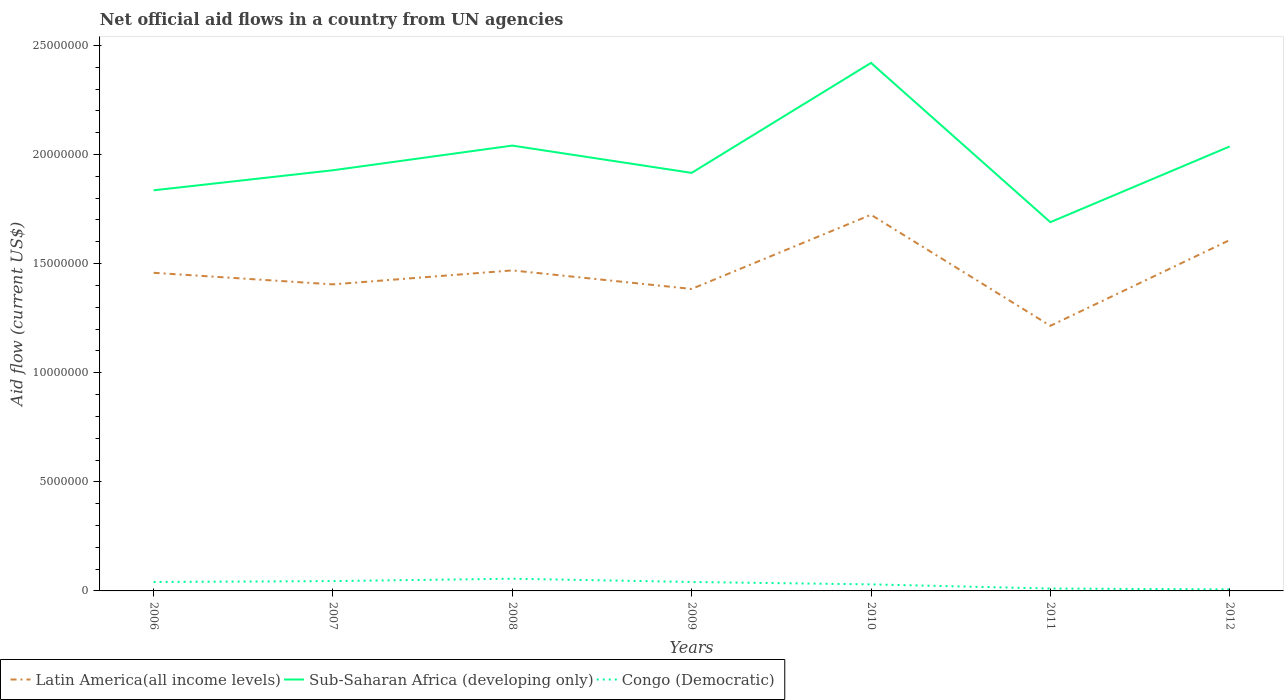Across all years, what is the maximum net official aid flow in Latin America(all income levels)?
Offer a very short reply. 1.22e+07. What is the total net official aid flow in Latin America(all income levels) in the graph?
Offer a very short reply. 2.10e+05. What is the difference between the highest and the second highest net official aid flow in Sub-Saharan Africa (developing only)?
Your answer should be compact. 7.30e+06. How many years are there in the graph?
Provide a short and direct response. 7. Are the values on the major ticks of Y-axis written in scientific E-notation?
Provide a succinct answer. No. Does the graph contain any zero values?
Your answer should be compact. No. Where does the legend appear in the graph?
Your answer should be very brief. Bottom left. How many legend labels are there?
Ensure brevity in your answer.  3. What is the title of the graph?
Your answer should be compact. Net official aid flows in a country from UN agencies. What is the Aid flow (current US$) in Latin America(all income levels) in 2006?
Your response must be concise. 1.46e+07. What is the Aid flow (current US$) in Sub-Saharan Africa (developing only) in 2006?
Provide a succinct answer. 1.84e+07. What is the Aid flow (current US$) in Congo (Democratic) in 2006?
Provide a succinct answer. 4.10e+05. What is the Aid flow (current US$) in Latin America(all income levels) in 2007?
Ensure brevity in your answer.  1.40e+07. What is the Aid flow (current US$) in Sub-Saharan Africa (developing only) in 2007?
Provide a succinct answer. 1.93e+07. What is the Aid flow (current US$) of Congo (Democratic) in 2007?
Provide a short and direct response. 4.50e+05. What is the Aid flow (current US$) in Latin America(all income levels) in 2008?
Your answer should be compact. 1.47e+07. What is the Aid flow (current US$) in Sub-Saharan Africa (developing only) in 2008?
Provide a short and direct response. 2.04e+07. What is the Aid flow (current US$) in Congo (Democratic) in 2008?
Make the answer very short. 5.60e+05. What is the Aid flow (current US$) of Latin America(all income levels) in 2009?
Your answer should be compact. 1.38e+07. What is the Aid flow (current US$) of Sub-Saharan Africa (developing only) in 2009?
Offer a terse response. 1.92e+07. What is the Aid flow (current US$) of Latin America(all income levels) in 2010?
Offer a terse response. 1.72e+07. What is the Aid flow (current US$) of Sub-Saharan Africa (developing only) in 2010?
Provide a short and direct response. 2.42e+07. What is the Aid flow (current US$) of Latin America(all income levels) in 2011?
Make the answer very short. 1.22e+07. What is the Aid flow (current US$) in Sub-Saharan Africa (developing only) in 2011?
Your answer should be very brief. 1.69e+07. What is the Aid flow (current US$) of Congo (Democratic) in 2011?
Your answer should be compact. 1.10e+05. What is the Aid flow (current US$) of Latin America(all income levels) in 2012?
Provide a short and direct response. 1.61e+07. What is the Aid flow (current US$) in Sub-Saharan Africa (developing only) in 2012?
Provide a succinct answer. 2.04e+07. Across all years, what is the maximum Aid flow (current US$) in Latin America(all income levels)?
Your answer should be compact. 1.72e+07. Across all years, what is the maximum Aid flow (current US$) in Sub-Saharan Africa (developing only)?
Your response must be concise. 2.42e+07. Across all years, what is the maximum Aid flow (current US$) of Congo (Democratic)?
Give a very brief answer. 5.60e+05. Across all years, what is the minimum Aid flow (current US$) in Latin America(all income levels)?
Keep it short and to the point. 1.22e+07. Across all years, what is the minimum Aid flow (current US$) in Sub-Saharan Africa (developing only)?
Offer a very short reply. 1.69e+07. What is the total Aid flow (current US$) of Latin America(all income levels) in the graph?
Your answer should be very brief. 1.03e+08. What is the total Aid flow (current US$) in Sub-Saharan Africa (developing only) in the graph?
Ensure brevity in your answer.  1.39e+08. What is the total Aid flow (current US$) in Congo (Democratic) in the graph?
Ensure brevity in your answer.  2.31e+06. What is the difference between the Aid flow (current US$) in Latin America(all income levels) in 2006 and that in 2007?
Your answer should be very brief. 5.30e+05. What is the difference between the Aid flow (current US$) in Sub-Saharan Africa (developing only) in 2006 and that in 2007?
Your response must be concise. -9.20e+05. What is the difference between the Aid flow (current US$) of Congo (Democratic) in 2006 and that in 2007?
Offer a terse response. -4.00e+04. What is the difference between the Aid flow (current US$) in Sub-Saharan Africa (developing only) in 2006 and that in 2008?
Offer a terse response. -2.05e+06. What is the difference between the Aid flow (current US$) of Latin America(all income levels) in 2006 and that in 2009?
Ensure brevity in your answer.  7.40e+05. What is the difference between the Aid flow (current US$) in Sub-Saharan Africa (developing only) in 2006 and that in 2009?
Provide a succinct answer. -8.00e+05. What is the difference between the Aid flow (current US$) in Congo (Democratic) in 2006 and that in 2009?
Your answer should be very brief. 0. What is the difference between the Aid flow (current US$) of Latin America(all income levels) in 2006 and that in 2010?
Your answer should be very brief. -2.66e+06. What is the difference between the Aid flow (current US$) in Sub-Saharan Africa (developing only) in 2006 and that in 2010?
Your answer should be very brief. -5.84e+06. What is the difference between the Aid flow (current US$) of Latin America(all income levels) in 2006 and that in 2011?
Provide a succinct answer. 2.43e+06. What is the difference between the Aid flow (current US$) of Sub-Saharan Africa (developing only) in 2006 and that in 2011?
Your answer should be compact. 1.46e+06. What is the difference between the Aid flow (current US$) of Congo (Democratic) in 2006 and that in 2011?
Provide a succinct answer. 3.00e+05. What is the difference between the Aid flow (current US$) of Latin America(all income levels) in 2006 and that in 2012?
Offer a terse response. -1.50e+06. What is the difference between the Aid flow (current US$) in Sub-Saharan Africa (developing only) in 2006 and that in 2012?
Provide a succinct answer. -2.01e+06. What is the difference between the Aid flow (current US$) of Latin America(all income levels) in 2007 and that in 2008?
Offer a terse response. -6.40e+05. What is the difference between the Aid flow (current US$) in Sub-Saharan Africa (developing only) in 2007 and that in 2008?
Provide a short and direct response. -1.13e+06. What is the difference between the Aid flow (current US$) of Congo (Democratic) in 2007 and that in 2008?
Your response must be concise. -1.10e+05. What is the difference between the Aid flow (current US$) of Sub-Saharan Africa (developing only) in 2007 and that in 2009?
Offer a terse response. 1.20e+05. What is the difference between the Aid flow (current US$) of Congo (Democratic) in 2007 and that in 2009?
Offer a terse response. 4.00e+04. What is the difference between the Aid flow (current US$) of Latin America(all income levels) in 2007 and that in 2010?
Offer a terse response. -3.19e+06. What is the difference between the Aid flow (current US$) of Sub-Saharan Africa (developing only) in 2007 and that in 2010?
Provide a short and direct response. -4.92e+06. What is the difference between the Aid flow (current US$) in Latin America(all income levels) in 2007 and that in 2011?
Provide a succinct answer. 1.90e+06. What is the difference between the Aid flow (current US$) in Sub-Saharan Africa (developing only) in 2007 and that in 2011?
Provide a short and direct response. 2.38e+06. What is the difference between the Aid flow (current US$) in Congo (Democratic) in 2007 and that in 2011?
Offer a terse response. 3.40e+05. What is the difference between the Aid flow (current US$) of Latin America(all income levels) in 2007 and that in 2012?
Your answer should be very brief. -2.03e+06. What is the difference between the Aid flow (current US$) in Sub-Saharan Africa (developing only) in 2007 and that in 2012?
Provide a succinct answer. -1.09e+06. What is the difference between the Aid flow (current US$) of Latin America(all income levels) in 2008 and that in 2009?
Provide a succinct answer. 8.50e+05. What is the difference between the Aid flow (current US$) of Sub-Saharan Africa (developing only) in 2008 and that in 2009?
Your answer should be compact. 1.25e+06. What is the difference between the Aid flow (current US$) of Latin America(all income levels) in 2008 and that in 2010?
Offer a terse response. -2.55e+06. What is the difference between the Aid flow (current US$) in Sub-Saharan Africa (developing only) in 2008 and that in 2010?
Give a very brief answer. -3.79e+06. What is the difference between the Aid flow (current US$) in Latin America(all income levels) in 2008 and that in 2011?
Ensure brevity in your answer.  2.54e+06. What is the difference between the Aid flow (current US$) in Sub-Saharan Africa (developing only) in 2008 and that in 2011?
Make the answer very short. 3.51e+06. What is the difference between the Aid flow (current US$) in Congo (Democratic) in 2008 and that in 2011?
Provide a short and direct response. 4.50e+05. What is the difference between the Aid flow (current US$) in Latin America(all income levels) in 2008 and that in 2012?
Offer a very short reply. -1.39e+06. What is the difference between the Aid flow (current US$) of Congo (Democratic) in 2008 and that in 2012?
Make the answer very short. 4.90e+05. What is the difference between the Aid flow (current US$) of Latin America(all income levels) in 2009 and that in 2010?
Your response must be concise. -3.40e+06. What is the difference between the Aid flow (current US$) in Sub-Saharan Africa (developing only) in 2009 and that in 2010?
Give a very brief answer. -5.04e+06. What is the difference between the Aid flow (current US$) in Latin America(all income levels) in 2009 and that in 2011?
Offer a very short reply. 1.69e+06. What is the difference between the Aid flow (current US$) in Sub-Saharan Africa (developing only) in 2009 and that in 2011?
Provide a succinct answer. 2.26e+06. What is the difference between the Aid flow (current US$) of Latin America(all income levels) in 2009 and that in 2012?
Your answer should be very brief. -2.24e+06. What is the difference between the Aid flow (current US$) in Sub-Saharan Africa (developing only) in 2009 and that in 2012?
Your answer should be compact. -1.21e+06. What is the difference between the Aid flow (current US$) in Latin America(all income levels) in 2010 and that in 2011?
Your response must be concise. 5.09e+06. What is the difference between the Aid flow (current US$) in Sub-Saharan Africa (developing only) in 2010 and that in 2011?
Your answer should be compact. 7.30e+06. What is the difference between the Aid flow (current US$) in Congo (Democratic) in 2010 and that in 2011?
Your answer should be very brief. 1.90e+05. What is the difference between the Aid flow (current US$) of Latin America(all income levels) in 2010 and that in 2012?
Give a very brief answer. 1.16e+06. What is the difference between the Aid flow (current US$) of Sub-Saharan Africa (developing only) in 2010 and that in 2012?
Give a very brief answer. 3.83e+06. What is the difference between the Aid flow (current US$) of Latin America(all income levels) in 2011 and that in 2012?
Your answer should be compact. -3.93e+06. What is the difference between the Aid flow (current US$) of Sub-Saharan Africa (developing only) in 2011 and that in 2012?
Your answer should be very brief. -3.47e+06. What is the difference between the Aid flow (current US$) in Latin America(all income levels) in 2006 and the Aid flow (current US$) in Sub-Saharan Africa (developing only) in 2007?
Provide a succinct answer. -4.70e+06. What is the difference between the Aid flow (current US$) in Latin America(all income levels) in 2006 and the Aid flow (current US$) in Congo (Democratic) in 2007?
Ensure brevity in your answer.  1.41e+07. What is the difference between the Aid flow (current US$) in Sub-Saharan Africa (developing only) in 2006 and the Aid flow (current US$) in Congo (Democratic) in 2007?
Keep it short and to the point. 1.79e+07. What is the difference between the Aid flow (current US$) in Latin America(all income levels) in 2006 and the Aid flow (current US$) in Sub-Saharan Africa (developing only) in 2008?
Ensure brevity in your answer.  -5.83e+06. What is the difference between the Aid flow (current US$) in Latin America(all income levels) in 2006 and the Aid flow (current US$) in Congo (Democratic) in 2008?
Give a very brief answer. 1.40e+07. What is the difference between the Aid flow (current US$) of Sub-Saharan Africa (developing only) in 2006 and the Aid flow (current US$) of Congo (Democratic) in 2008?
Offer a very short reply. 1.78e+07. What is the difference between the Aid flow (current US$) in Latin America(all income levels) in 2006 and the Aid flow (current US$) in Sub-Saharan Africa (developing only) in 2009?
Offer a terse response. -4.58e+06. What is the difference between the Aid flow (current US$) in Latin America(all income levels) in 2006 and the Aid flow (current US$) in Congo (Democratic) in 2009?
Your answer should be compact. 1.42e+07. What is the difference between the Aid flow (current US$) in Sub-Saharan Africa (developing only) in 2006 and the Aid flow (current US$) in Congo (Democratic) in 2009?
Your response must be concise. 1.80e+07. What is the difference between the Aid flow (current US$) of Latin America(all income levels) in 2006 and the Aid flow (current US$) of Sub-Saharan Africa (developing only) in 2010?
Offer a very short reply. -9.62e+06. What is the difference between the Aid flow (current US$) of Latin America(all income levels) in 2006 and the Aid flow (current US$) of Congo (Democratic) in 2010?
Keep it short and to the point. 1.43e+07. What is the difference between the Aid flow (current US$) in Sub-Saharan Africa (developing only) in 2006 and the Aid flow (current US$) in Congo (Democratic) in 2010?
Your answer should be compact. 1.81e+07. What is the difference between the Aid flow (current US$) in Latin America(all income levels) in 2006 and the Aid flow (current US$) in Sub-Saharan Africa (developing only) in 2011?
Ensure brevity in your answer.  -2.32e+06. What is the difference between the Aid flow (current US$) of Latin America(all income levels) in 2006 and the Aid flow (current US$) of Congo (Democratic) in 2011?
Offer a terse response. 1.45e+07. What is the difference between the Aid flow (current US$) of Sub-Saharan Africa (developing only) in 2006 and the Aid flow (current US$) of Congo (Democratic) in 2011?
Give a very brief answer. 1.82e+07. What is the difference between the Aid flow (current US$) of Latin America(all income levels) in 2006 and the Aid flow (current US$) of Sub-Saharan Africa (developing only) in 2012?
Provide a short and direct response. -5.79e+06. What is the difference between the Aid flow (current US$) of Latin America(all income levels) in 2006 and the Aid flow (current US$) of Congo (Democratic) in 2012?
Ensure brevity in your answer.  1.45e+07. What is the difference between the Aid flow (current US$) of Sub-Saharan Africa (developing only) in 2006 and the Aid flow (current US$) of Congo (Democratic) in 2012?
Your answer should be very brief. 1.83e+07. What is the difference between the Aid flow (current US$) in Latin America(all income levels) in 2007 and the Aid flow (current US$) in Sub-Saharan Africa (developing only) in 2008?
Make the answer very short. -6.36e+06. What is the difference between the Aid flow (current US$) of Latin America(all income levels) in 2007 and the Aid flow (current US$) of Congo (Democratic) in 2008?
Ensure brevity in your answer.  1.35e+07. What is the difference between the Aid flow (current US$) of Sub-Saharan Africa (developing only) in 2007 and the Aid flow (current US$) of Congo (Democratic) in 2008?
Your answer should be very brief. 1.87e+07. What is the difference between the Aid flow (current US$) in Latin America(all income levels) in 2007 and the Aid flow (current US$) in Sub-Saharan Africa (developing only) in 2009?
Your answer should be very brief. -5.11e+06. What is the difference between the Aid flow (current US$) of Latin America(all income levels) in 2007 and the Aid flow (current US$) of Congo (Democratic) in 2009?
Offer a terse response. 1.36e+07. What is the difference between the Aid flow (current US$) of Sub-Saharan Africa (developing only) in 2007 and the Aid flow (current US$) of Congo (Democratic) in 2009?
Provide a short and direct response. 1.89e+07. What is the difference between the Aid flow (current US$) of Latin America(all income levels) in 2007 and the Aid flow (current US$) of Sub-Saharan Africa (developing only) in 2010?
Your answer should be compact. -1.02e+07. What is the difference between the Aid flow (current US$) of Latin America(all income levels) in 2007 and the Aid flow (current US$) of Congo (Democratic) in 2010?
Give a very brief answer. 1.38e+07. What is the difference between the Aid flow (current US$) in Sub-Saharan Africa (developing only) in 2007 and the Aid flow (current US$) in Congo (Democratic) in 2010?
Give a very brief answer. 1.90e+07. What is the difference between the Aid flow (current US$) in Latin America(all income levels) in 2007 and the Aid flow (current US$) in Sub-Saharan Africa (developing only) in 2011?
Ensure brevity in your answer.  -2.85e+06. What is the difference between the Aid flow (current US$) of Latin America(all income levels) in 2007 and the Aid flow (current US$) of Congo (Democratic) in 2011?
Give a very brief answer. 1.39e+07. What is the difference between the Aid flow (current US$) in Sub-Saharan Africa (developing only) in 2007 and the Aid flow (current US$) in Congo (Democratic) in 2011?
Your answer should be compact. 1.92e+07. What is the difference between the Aid flow (current US$) in Latin America(all income levels) in 2007 and the Aid flow (current US$) in Sub-Saharan Africa (developing only) in 2012?
Provide a succinct answer. -6.32e+06. What is the difference between the Aid flow (current US$) of Latin America(all income levels) in 2007 and the Aid flow (current US$) of Congo (Democratic) in 2012?
Your answer should be very brief. 1.40e+07. What is the difference between the Aid flow (current US$) of Sub-Saharan Africa (developing only) in 2007 and the Aid flow (current US$) of Congo (Democratic) in 2012?
Make the answer very short. 1.92e+07. What is the difference between the Aid flow (current US$) of Latin America(all income levels) in 2008 and the Aid flow (current US$) of Sub-Saharan Africa (developing only) in 2009?
Provide a succinct answer. -4.47e+06. What is the difference between the Aid flow (current US$) in Latin America(all income levels) in 2008 and the Aid flow (current US$) in Congo (Democratic) in 2009?
Give a very brief answer. 1.43e+07. What is the difference between the Aid flow (current US$) of Latin America(all income levels) in 2008 and the Aid flow (current US$) of Sub-Saharan Africa (developing only) in 2010?
Give a very brief answer. -9.51e+06. What is the difference between the Aid flow (current US$) of Latin America(all income levels) in 2008 and the Aid flow (current US$) of Congo (Democratic) in 2010?
Provide a short and direct response. 1.44e+07. What is the difference between the Aid flow (current US$) in Sub-Saharan Africa (developing only) in 2008 and the Aid flow (current US$) in Congo (Democratic) in 2010?
Your answer should be very brief. 2.01e+07. What is the difference between the Aid flow (current US$) of Latin America(all income levels) in 2008 and the Aid flow (current US$) of Sub-Saharan Africa (developing only) in 2011?
Provide a short and direct response. -2.21e+06. What is the difference between the Aid flow (current US$) in Latin America(all income levels) in 2008 and the Aid flow (current US$) in Congo (Democratic) in 2011?
Keep it short and to the point. 1.46e+07. What is the difference between the Aid flow (current US$) of Sub-Saharan Africa (developing only) in 2008 and the Aid flow (current US$) of Congo (Democratic) in 2011?
Ensure brevity in your answer.  2.03e+07. What is the difference between the Aid flow (current US$) of Latin America(all income levels) in 2008 and the Aid flow (current US$) of Sub-Saharan Africa (developing only) in 2012?
Ensure brevity in your answer.  -5.68e+06. What is the difference between the Aid flow (current US$) of Latin America(all income levels) in 2008 and the Aid flow (current US$) of Congo (Democratic) in 2012?
Keep it short and to the point. 1.46e+07. What is the difference between the Aid flow (current US$) of Sub-Saharan Africa (developing only) in 2008 and the Aid flow (current US$) of Congo (Democratic) in 2012?
Your response must be concise. 2.03e+07. What is the difference between the Aid flow (current US$) of Latin America(all income levels) in 2009 and the Aid flow (current US$) of Sub-Saharan Africa (developing only) in 2010?
Make the answer very short. -1.04e+07. What is the difference between the Aid flow (current US$) of Latin America(all income levels) in 2009 and the Aid flow (current US$) of Congo (Democratic) in 2010?
Provide a succinct answer. 1.35e+07. What is the difference between the Aid flow (current US$) in Sub-Saharan Africa (developing only) in 2009 and the Aid flow (current US$) in Congo (Democratic) in 2010?
Ensure brevity in your answer.  1.89e+07. What is the difference between the Aid flow (current US$) in Latin America(all income levels) in 2009 and the Aid flow (current US$) in Sub-Saharan Africa (developing only) in 2011?
Give a very brief answer. -3.06e+06. What is the difference between the Aid flow (current US$) in Latin America(all income levels) in 2009 and the Aid flow (current US$) in Congo (Democratic) in 2011?
Make the answer very short. 1.37e+07. What is the difference between the Aid flow (current US$) of Sub-Saharan Africa (developing only) in 2009 and the Aid flow (current US$) of Congo (Democratic) in 2011?
Your answer should be very brief. 1.90e+07. What is the difference between the Aid flow (current US$) in Latin America(all income levels) in 2009 and the Aid flow (current US$) in Sub-Saharan Africa (developing only) in 2012?
Provide a succinct answer. -6.53e+06. What is the difference between the Aid flow (current US$) in Latin America(all income levels) in 2009 and the Aid flow (current US$) in Congo (Democratic) in 2012?
Provide a short and direct response. 1.38e+07. What is the difference between the Aid flow (current US$) of Sub-Saharan Africa (developing only) in 2009 and the Aid flow (current US$) of Congo (Democratic) in 2012?
Provide a succinct answer. 1.91e+07. What is the difference between the Aid flow (current US$) of Latin America(all income levels) in 2010 and the Aid flow (current US$) of Congo (Democratic) in 2011?
Your answer should be compact. 1.71e+07. What is the difference between the Aid flow (current US$) of Sub-Saharan Africa (developing only) in 2010 and the Aid flow (current US$) of Congo (Democratic) in 2011?
Provide a succinct answer. 2.41e+07. What is the difference between the Aid flow (current US$) of Latin America(all income levels) in 2010 and the Aid flow (current US$) of Sub-Saharan Africa (developing only) in 2012?
Give a very brief answer. -3.13e+06. What is the difference between the Aid flow (current US$) in Latin America(all income levels) in 2010 and the Aid flow (current US$) in Congo (Democratic) in 2012?
Provide a succinct answer. 1.72e+07. What is the difference between the Aid flow (current US$) of Sub-Saharan Africa (developing only) in 2010 and the Aid flow (current US$) of Congo (Democratic) in 2012?
Give a very brief answer. 2.41e+07. What is the difference between the Aid flow (current US$) in Latin America(all income levels) in 2011 and the Aid flow (current US$) in Sub-Saharan Africa (developing only) in 2012?
Keep it short and to the point. -8.22e+06. What is the difference between the Aid flow (current US$) of Latin America(all income levels) in 2011 and the Aid flow (current US$) of Congo (Democratic) in 2012?
Give a very brief answer. 1.21e+07. What is the difference between the Aid flow (current US$) in Sub-Saharan Africa (developing only) in 2011 and the Aid flow (current US$) in Congo (Democratic) in 2012?
Give a very brief answer. 1.68e+07. What is the average Aid flow (current US$) in Latin America(all income levels) per year?
Your answer should be compact. 1.47e+07. What is the average Aid flow (current US$) of Sub-Saharan Africa (developing only) per year?
Offer a terse response. 1.98e+07. In the year 2006, what is the difference between the Aid flow (current US$) of Latin America(all income levels) and Aid flow (current US$) of Sub-Saharan Africa (developing only)?
Keep it short and to the point. -3.78e+06. In the year 2006, what is the difference between the Aid flow (current US$) in Latin America(all income levels) and Aid flow (current US$) in Congo (Democratic)?
Make the answer very short. 1.42e+07. In the year 2006, what is the difference between the Aid flow (current US$) of Sub-Saharan Africa (developing only) and Aid flow (current US$) of Congo (Democratic)?
Offer a terse response. 1.80e+07. In the year 2007, what is the difference between the Aid flow (current US$) in Latin America(all income levels) and Aid flow (current US$) in Sub-Saharan Africa (developing only)?
Offer a very short reply. -5.23e+06. In the year 2007, what is the difference between the Aid flow (current US$) of Latin America(all income levels) and Aid flow (current US$) of Congo (Democratic)?
Keep it short and to the point. 1.36e+07. In the year 2007, what is the difference between the Aid flow (current US$) of Sub-Saharan Africa (developing only) and Aid flow (current US$) of Congo (Democratic)?
Make the answer very short. 1.88e+07. In the year 2008, what is the difference between the Aid flow (current US$) in Latin America(all income levels) and Aid flow (current US$) in Sub-Saharan Africa (developing only)?
Give a very brief answer. -5.72e+06. In the year 2008, what is the difference between the Aid flow (current US$) in Latin America(all income levels) and Aid flow (current US$) in Congo (Democratic)?
Your response must be concise. 1.41e+07. In the year 2008, what is the difference between the Aid flow (current US$) in Sub-Saharan Africa (developing only) and Aid flow (current US$) in Congo (Democratic)?
Provide a short and direct response. 1.98e+07. In the year 2009, what is the difference between the Aid flow (current US$) in Latin America(all income levels) and Aid flow (current US$) in Sub-Saharan Africa (developing only)?
Offer a terse response. -5.32e+06. In the year 2009, what is the difference between the Aid flow (current US$) of Latin America(all income levels) and Aid flow (current US$) of Congo (Democratic)?
Your response must be concise. 1.34e+07. In the year 2009, what is the difference between the Aid flow (current US$) of Sub-Saharan Africa (developing only) and Aid flow (current US$) of Congo (Democratic)?
Provide a short and direct response. 1.88e+07. In the year 2010, what is the difference between the Aid flow (current US$) in Latin America(all income levels) and Aid flow (current US$) in Sub-Saharan Africa (developing only)?
Provide a short and direct response. -6.96e+06. In the year 2010, what is the difference between the Aid flow (current US$) of Latin America(all income levels) and Aid flow (current US$) of Congo (Democratic)?
Offer a terse response. 1.69e+07. In the year 2010, what is the difference between the Aid flow (current US$) of Sub-Saharan Africa (developing only) and Aid flow (current US$) of Congo (Democratic)?
Keep it short and to the point. 2.39e+07. In the year 2011, what is the difference between the Aid flow (current US$) of Latin America(all income levels) and Aid flow (current US$) of Sub-Saharan Africa (developing only)?
Make the answer very short. -4.75e+06. In the year 2011, what is the difference between the Aid flow (current US$) of Latin America(all income levels) and Aid flow (current US$) of Congo (Democratic)?
Your response must be concise. 1.20e+07. In the year 2011, what is the difference between the Aid flow (current US$) in Sub-Saharan Africa (developing only) and Aid flow (current US$) in Congo (Democratic)?
Keep it short and to the point. 1.68e+07. In the year 2012, what is the difference between the Aid flow (current US$) in Latin America(all income levels) and Aid flow (current US$) in Sub-Saharan Africa (developing only)?
Your answer should be very brief. -4.29e+06. In the year 2012, what is the difference between the Aid flow (current US$) in Latin America(all income levels) and Aid flow (current US$) in Congo (Democratic)?
Ensure brevity in your answer.  1.60e+07. In the year 2012, what is the difference between the Aid flow (current US$) in Sub-Saharan Africa (developing only) and Aid flow (current US$) in Congo (Democratic)?
Your answer should be compact. 2.03e+07. What is the ratio of the Aid flow (current US$) in Latin America(all income levels) in 2006 to that in 2007?
Provide a succinct answer. 1.04. What is the ratio of the Aid flow (current US$) of Sub-Saharan Africa (developing only) in 2006 to that in 2007?
Provide a succinct answer. 0.95. What is the ratio of the Aid flow (current US$) in Congo (Democratic) in 2006 to that in 2007?
Offer a terse response. 0.91. What is the ratio of the Aid flow (current US$) of Sub-Saharan Africa (developing only) in 2006 to that in 2008?
Make the answer very short. 0.9. What is the ratio of the Aid flow (current US$) of Congo (Democratic) in 2006 to that in 2008?
Your answer should be compact. 0.73. What is the ratio of the Aid flow (current US$) in Latin America(all income levels) in 2006 to that in 2009?
Your answer should be compact. 1.05. What is the ratio of the Aid flow (current US$) in Sub-Saharan Africa (developing only) in 2006 to that in 2009?
Give a very brief answer. 0.96. What is the ratio of the Aid flow (current US$) in Latin America(all income levels) in 2006 to that in 2010?
Your answer should be compact. 0.85. What is the ratio of the Aid flow (current US$) in Sub-Saharan Africa (developing only) in 2006 to that in 2010?
Offer a terse response. 0.76. What is the ratio of the Aid flow (current US$) of Congo (Democratic) in 2006 to that in 2010?
Ensure brevity in your answer.  1.37. What is the ratio of the Aid flow (current US$) in Latin America(all income levels) in 2006 to that in 2011?
Your response must be concise. 1.2. What is the ratio of the Aid flow (current US$) in Sub-Saharan Africa (developing only) in 2006 to that in 2011?
Your response must be concise. 1.09. What is the ratio of the Aid flow (current US$) in Congo (Democratic) in 2006 to that in 2011?
Keep it short and to the point. 3.73. What is the ratio of the Aid flow (current US$) of Latin America(all income levels) in 2006 to that in 2012?
Provide a succinct answer. 0.91. What is the ratio of the Aid flow (current US$) of Sub-Saharan Africa (developing only) in 2006 to that in 2012?
Provide a short and direct response. 0.9. What is the ratio of the Aid flow (current US$) in Congo (Democratic) in 2006 to that in 2012?
Make the answer very short. 5.86. What is the ratio of the Aid flow (current US$) of Latin America(all income levels) in 2007 to that in 2008?
Offer a very short reply. 0.96. What is the ratio of the Aid flow (current US$) in Sub-Saharan Africa (developing only) in 2007 to that in 2008?
Your response must be concise. 0.94. What is the ratio of the Aid flow (current US$) of Congo (Democratic) in 2007 to that in 2008?
Ensure brevity in your answer.  0.8. What is the ratio of the Aid flow (current US$) of Latin America(all income levels) in 2007 to that in 2009?
Provide a succinct answer. 1.02. What is the ratio of the Aid flow (current US$) in Sub-Saharan Africa (developing only) in 2007 to that in 2009?
Offer a very short reply. 1.01. What is the ratio of the Aid flow (current US$) in Congo (Democratic) in 2007 to that in 2009?
Your response must be concise. 1.1. What is the ratio of the Aid flow (current US$) in Latin America(all income levels) in 2007 to that in 2010?
Your answer should be compact. 0.81. What is the ratio of the Aid flow (current US$) of Sub-Saharan Africa (developing only) in 2007 to that in 2010?
Provide a succinct answer. 0.8. What is the ratio of the Aid flow (current US$) in Congo (Democratic) in 2007 to that in 2010?
Provide a succinct answer. 1.5. What is the ratio of the Aid flow (current US$) of Latin America(all income levels) in 2007 to that in 2011?
Your answer should be very brief. 1.16. What is the ratio of the Aid flow (current US$) in Sub-Saharan Africa (developing only) in 2007 to that in 2011?
Provide a short and direct response. 1.14. What is the ratio of the Aid flow (current US$) of Congo (Democratic) in 2007 to that in 2011?
Offer a very short reply. 4.09. What is the ratio of the Aid flow (current US$) in Latin America(all income levels) in 2007 to that in 2012?
Your answer should be very brief. 0.87. What is the ratio of the Aid flow (current US$) in Sub-Saharan Africa (developing only) in 2007 to that in 2012?
Your answer should be compact. 0.95. What is the ratio of the Aid flow (current US$) of Congo (Democratic) in 2007 to that in 2012?
Provide a short and direct response. 6.43. What is the ratio of the Aid flow (current US$) in Latin America(all income levels) in 2008 to that in 2009?
Provide a succinct answer. 1.06. What is the ratio of the Aid flow (current US$) in Sub-Saharan Africa (developing only) in 2008 to that in 2009?
Offer a terse response. 1.07. What is the ratio of the Aid flow (current US$) of Congo (Democratic) in 2008 to that in 2009?
Your answer should be very brief. 1.37. What is the ratio of the Aid flow (current US$) in Latin America(all income levels) in 2008 to that in 2010?
Offer a terse response. 0.85. What is the ratio of the Aid flow (current US$) in Sub-Saharan Africa (developing only) in 2008 to that in 2010?
Offer a very short reply. 0.84. What is the ratio of the Aid flow (current US$) in Congo (Democratic) in 2008 to that in 2010?
Keep it short and to the point. 1.87. What is the ratio of the Aid flow (current US$) in Latin America(all income levels) in 2008 to that in 2011?
Offer a terse response. 1.21. What is the ratio of the Aid flow (current US$) in Sub-Saharan Africa (developing only) in 2008 to that in 2011?
Make the answer very short. 1.21. What is the ratio of the Aid flow (current US$) of Congo (Democratic) in 2008 to that in 2011?
Your answer should be compact. 5.09. What is the ratio of the Aid flow (current US$) of Latin America(all income levels) in 2008 to that in 2012?
Give a very brief answer. 0.91. What is the ratio of the Aid flow (current US$) of Latin America(all income levels) in 2009 to that in 2010?
Offer a very short reply. 0.8. What is the ratio of the Aid flow (current US$) of Sub-Saharan Africa (developing only) in 2009 to that in 2010?
Your response must be concise. 0.79. What is the ratio of the Aid flow (current US$) of Congo (Democratic) in 2009 to that in 2010?
Your answer should be compact. 1.37. What is the ratio of the Aid flow (current US$) in Latin America(all income levels) in 2009 to that in 2011?
Your response must be concise. 1.14. What is the ratio of the Aid flow (current US$) in Sub-Saharan Africa (developing only) in 2009 to that in 2011?
Provide a short and direct response. 1.13. What is the ratio of the Aid flow (current US$) of Congo (Democratic) in 2009 to that in 2011?
Give a very brief answer. 3.73. What is the ratio of the Aid flow (current US$) of Latin America(all income levels) in 2009 to that in 2012?
Provide a short and direct response. 0.86. What is the ratio of the Aid flow (current US$) in Sub-Saharan Africa (developing only) in 2009 to that in 2012?
Offer a very short reply. 0.94. What is the ratio of the Aid flow (current US$) of Congo (Democratic) in 2009 to that in 2012?
Your response must be concise. 5.86. What is the ratio of the Aid flow (current US$) in Latin America(all income levels) in 2010 to that in 2011?
Your answer should be compact. 1.42. What is the ratio of the Aid flow (current US$) of Sub-Saharan Africa (developing only) in 2010 to that in 2011?
Your answer should be compact. 1.43. What is the ratio of the Aid flow (current US$) in Congo (Democratic) in 2010 to that in 2011?
Offer a terse response. 2.73. What is the ratio of the Aid flow (current US$) of Latin America(all income levels) in 2010 to that in 2012?
Provide a short and direct response. 1.07. What is the ratio of the Aid flow (current US$) in Sub-Saharan Africa (developing only) in 2010 to that in 2012?
Your answer should be compact. 1.19. What is the ratio of the Aid flow (current US$) in Congo (Democratic) in 2010 to that in 2012?
Your response must be concise. 4.29. What is the ratio of the Aid flow (current US$) in Latin America(all income levels) in 2011 to that in 2012?
Offer a terse response. 0.76. What is the ratio of the Aid flow (current US$) in Sub-Saharan Africa (developing only) in 2011 to that in 2012?
Keep it short and to the point. 0.83. What is the ratio of the Aid flow (current US$) in Congo (Democratic) in 2011 to that in 2012?
Your answer should be compact. 1.57. What is the difference between the highest and the second highest Aid flow (current US$) of Latin America(all income levels)?
Offer a very short reply. 1.16e+06. What is the difference between the highest and the second highest Aid flow (current US$) in Sub-Saharan Africa (developing only)?
Ensure brevity in your answer.  3.79e+06. What is the difference between the highest and the second highest Aid flow (current US$) of Congo (Democratic)?
Offer a very short reply. 1.10e+05. What is the difference between the highest and the lowest Aid flow (current US$) in Latin America(all income levels)?
Your answer should be compact. 5.09e+06. What is the difference between the highest and the lowest Aid flow (current US$) of Sub-Saharan Africa (developing only)?
Make the answer very short. 7.30e+06. What is the difference between the highest and the lowest Aid flow (current US$) in Congo (Democratic)?
Ensure brevity in your answer.  4.90e+05. 